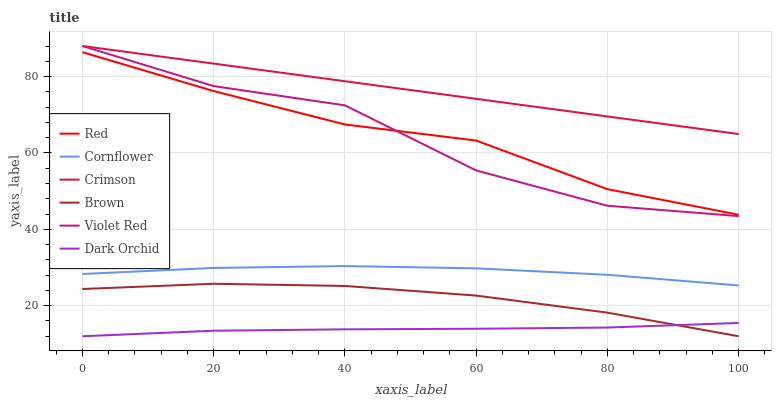Does Dark Orchid have the minimum area under the curve?
Answer yes or no. Yes. Does Crimson have the maximum area under the curve?
Answer yes or no. Yes. Does Violet Red have the minimum area under the curve?
Answer yes or no. No. Does Violet Red have the maximum area under the curve?
Answer yes or no. No. Is Crimson the smoothest?
Answer yes or no. Yes. Is Violet Red the roughest?
Answer yes or no. Yes. Is Brown the smoothest?
Answer yes or no. No. Is Brown the roughest?
Answer yes or no. No. Does Violet Red have the lowest value?
Answer yes or no. No. Does Crimson have the highest value?
Answer yes or no. Yes. Does Brown have the highest value?
Answer yes or no. No. Is Dark Orchid less than Violet Red?
Answer yes or no. Yes. Is Violet Red greater than Dark Orchid?
Answer yes or no. Yes. Does Brown intersect Dark Orchid?
Answer yes or no. Yes. Is Brown less than Dark Orchid?
Answer yes or no. No. Is Brown greater than Dark Orchid?
Answer yes or no. No. Does Dark Orchid intersect Violet Red?
Answer yes or no. No. 